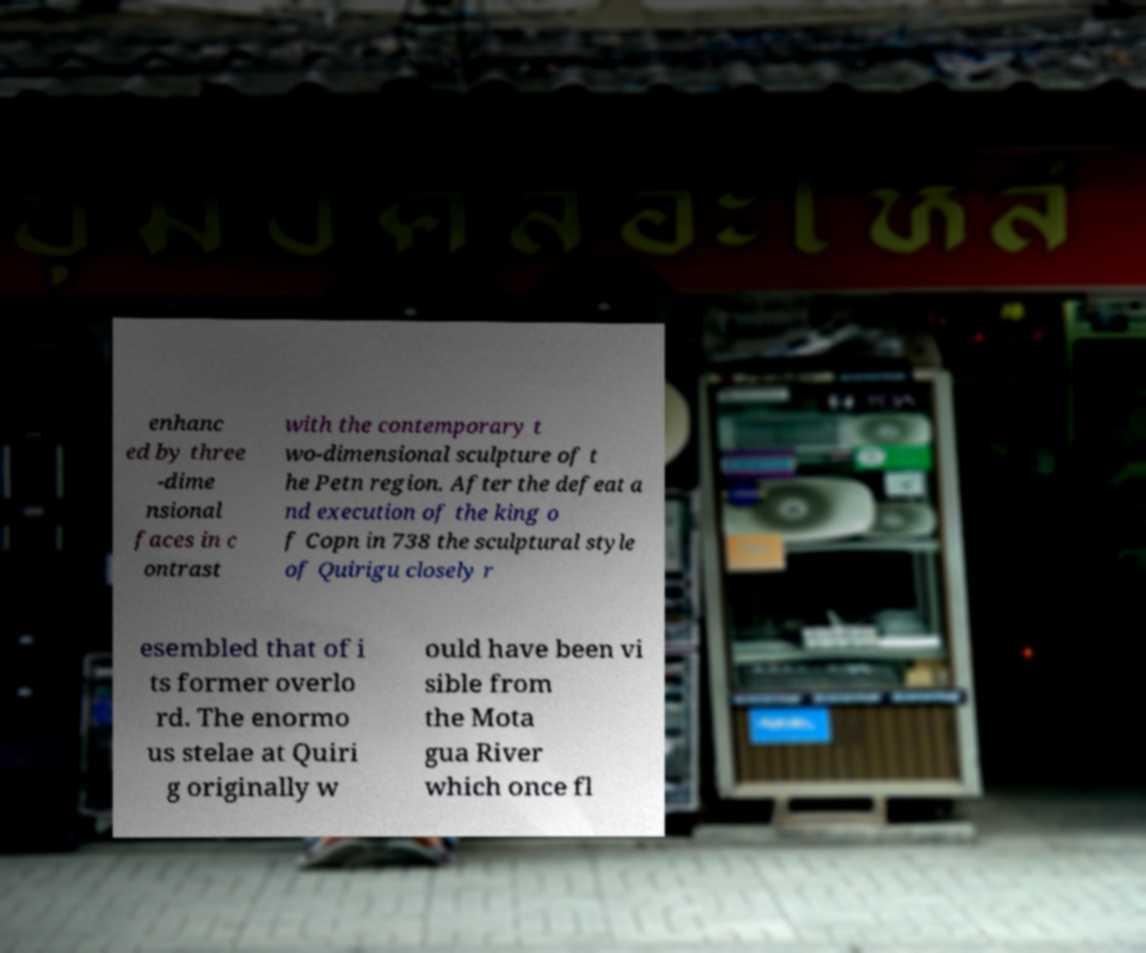Please identify and transcribe the text found in this image. enhanc ed by three -dime nsional faces in c ontrast with the contemporary t wo-dimensional sculpture of t he Petn region. After the defeat a nd execution of the king o f Copn in 738 the sculptural style of Quirigu closely r esembled that of i ts former overlo rd. The enormo us stelae at Quiri g originally w ould have been vi sible from the Mota gua River which once fl 